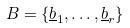<formula> <loc_0><loc_0><loc_500><loc_500>B = \{ \underline { b } _ { 1 } , \dots , \underline { b } _ { r } \}</formula> 